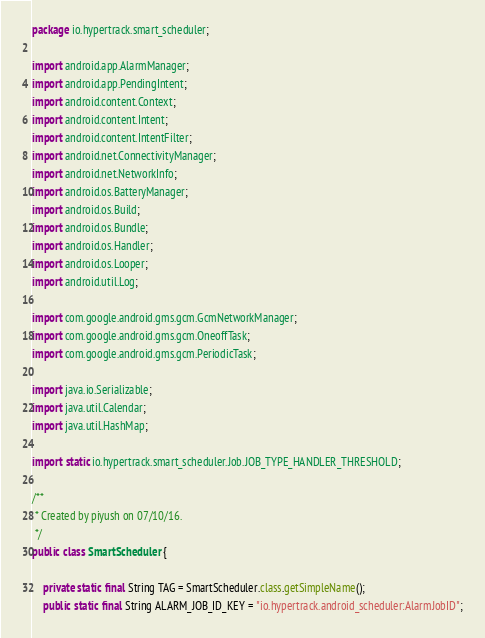<code> <loc_0><loc_0><loc_500><loc_500><_Java_>package io.hypertrack.smart_scheduler;

import android.app.AlarmManager;
import android.app.PendingIntent;
import android.content.Context;
import android.content.Intent;
import android.content.IntentFilter;
import android.net.ConnectivityManager;
import android.net.NetworkInfo;
import android.os.BatteryManager;
import android.os.Build;
import android.os.Bundle;
import android.os.Handler;
import android.os.Looper;
import android.util.Log;

import com.google.android.gms.gcm.GcmNetworkManager;
import com.google.android.gms.gcm.OneoffTask;
import com.google.android.gms.gcm.PeriodicTask;

import java.io.Serializable;
import java.util.Calendar;
import java.util.HashMap;

import static io.hypertrack.smart_scheduler.Job.JOB_TYPE_HANDLER_THRESHOLD;

/**
 * Created by piyush on 07/10/16.
 */
public class SmartScheduler {

    private static final String TAG = SmartScheduler.class.getSimpleName();
    public static final String ALARM_JOB_ID_KEY = "io.hypertrack.android_scheduler:AlarmJobID";</code> 